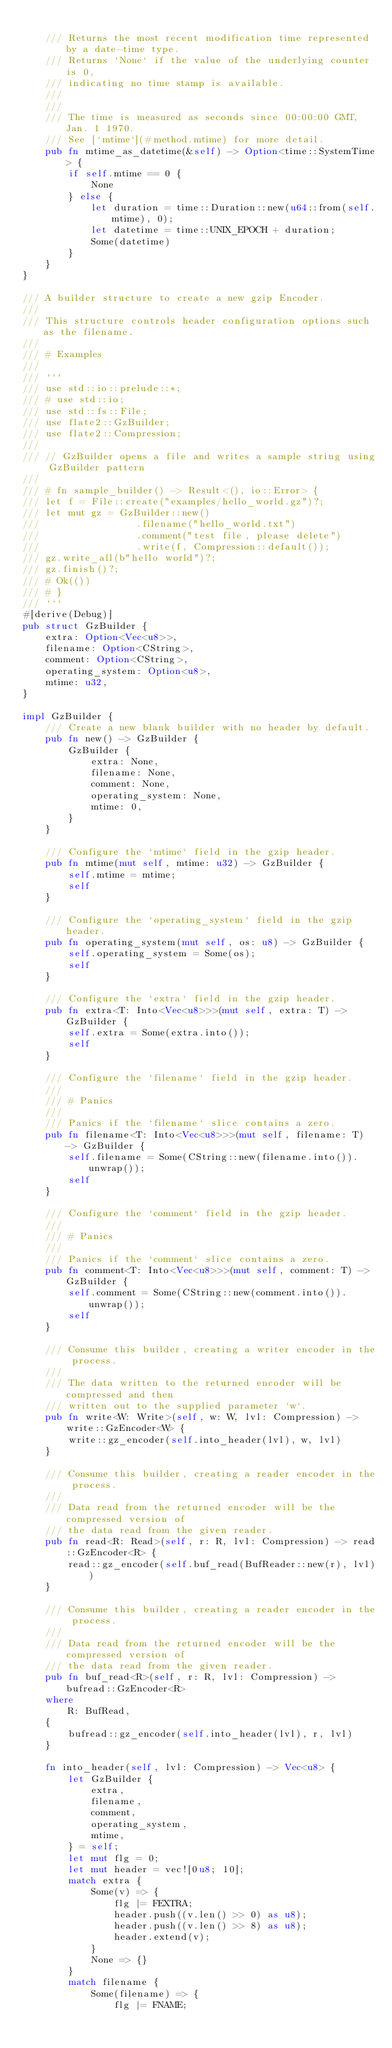<code> <loc_0><loc_0><loc_500><loc_500><_Rust_>
    /// Returns the most recent modification time represented by a date-time type.
    /// Returns `None` if the value of the underlying counter is 0,
    /// indicating no time stamp is available.
    ///
    ///
    /// The time is measured as seconds since 00:00:00 GMT, Jan. 1 1970.
    /// See [`mtime`](#method.mtime) for more detail.
    pub fn mtime_as_datetime(&self) -> Option<time::SystemTime> {
        if self.mtime == 0 {
            None
        } else {
            let duration = time::Duration::new(u64::from(self.mtime), 0);
            let datetime = time::UNIX_EPOCH + duration;
            Some(datetime)
        }
    }
}

/// A builder structure to create a new gzip Encoder.
///
/// This structure controls header configuration options such as the filename.
///
/// # Examples
///
/// ```
/// use std::io::prelude::*;
/// # use std::io;
/// use std::fs::File;
/// use flate2::GzBuilder;
/// use flate2::Compression;
///
/// // GzBuilder opens a file and writes a sample string using GzBuilder pattern
///
/// # fn sample_builder() -> Result<(), io::Error> {
/// let f = File::create("examples/hello_world.gz")?;
/// let mut gz = GzBuilder::new()
///                 .filename("hello_world.txt")
///                 .comment("test file, please delete")
///                 .write(f, Compression::default());
/// gz.write_all(b"hello world")?;
/// gz.finish()?;
/// # Ok(())
/// # }
/// ```
#[derive(Debug)]
pub struct GzBuilder {
    extra: Option<Vec<u8>>,
    filename: Option<CString>,
    comment: Option<CString>,
    operating_system: Option<u8>,
    mtime: u32,
}

impl GzBuilder {
    /// Create a new blank builder with no header by default.
    pub fn new() -> GzBuilder {
        GzBuilder {
            extra: None,
            filename: None,
            comment: None,
            operating_system: None,
            mtime: 0,
        }
    }

    /// Configure the `mtime` field in the gzip header.
    pub fn mtime(mut self, mtime: u32) -> GzBuilder {
        self.mtime = mtime;
        self
    }

    /// Configure the `operating_system` field in the gzip header.
    pub fn operating_system(mut self, os: u8) -> GzBuilder {
        self.operating_system = Some(os);
        self
    }

    /// Configure the `extra` field in the gzip header.
    pub fn extra<T: Into<Vec<u8>>>(mut self, extra: T) -> GzBuilder {
        self.extra = Some(extra.into());
        self
    }

    /// Configure the `filename` field in the gzip header.
    ///
    /// # Panics
    ///
    /// Panics if the `filename` slice contains a zero.
    pub fn filename<T: Into<Vec<u8>>>(mut self, filename: T) -> GzBuilder {
        self.filename = Some(CString::new(filename.into()).unwrap());
        self
    }

    /// Configure the `comment` field in the gzip header.
    ///
    /// # Panics
    ///
    /// Panics if the `comment` slice contains a zero.
    pub fn comment<T: Into<Vec<u8>>>(mut self, comment: T) -> GzBuilder {
        self.comment = Some(CString::new(comment.into()).unwrap());
        self
    }

    /// Consume this builder, creating a writer encoder in the process.
    ///
    /// The data written to the returned encoder will be compressed and then
    /// written out to the supplied parameter `w`.
    pub fn write<W: Write>(self, w: W, lvl: Compression) -> write::GzEncoder<W> {
        write::gz_encoder(self.into_header(lvl), w, lvl)
    }

    /// Consume this builder, creating a reader encoder in the process.
    ///
    /// Data read from the returned encoder will be the compressed version of
    /// the data read from the given reader.
    pub fn read<R: Read>(self, r: R, lvl: Compression) -> read::GzEncoder<R> {
        read::gz_encoder(self.buf_read(BufReader::new(r), lvl))
    }

    /// Consume this builder, creating a reader encoder in the process.
    ///
    /// Data read from the returned encoder will be the compressed version of
    /// the data read from the given reader.
    pub fn buf_read<R>(self, r: R, lvl: Compression) -> bufread::GzEncoder<R>
    where
        R: BufRead,
    {
        bufread::gz_encoder(self.into_header(lvl), r, lvl)
    }

    fn into_header(self, lvl: Compression) -> Vec<u8> {
        let GzBuilder {
            extra,
            filename,
            comment,
            operating_system,
            mtime,
        } = self;
        let mut flg = 0;
        let mut header = vec![0u8; 10];
        match extra {
            Some(v) => {
                flg |= FEXTRA;
                header.push((v.len() >> 0) as u8);
                header.push((v.len() >> 8) as u8);
                header.extend(v);
            }
            None => {}
        }
        match filename {
            Some(filename) => {
                flg |= FNAME;</code> 